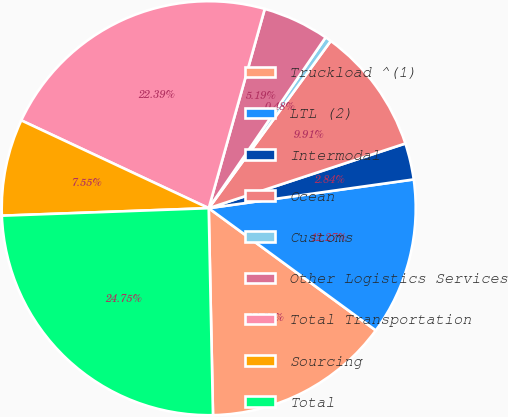Convert chart. <chart><loc_0><loc_0><loc_500><loc_500><pie_chart><fcel>Truckload ^(1)<fcel>LTL (2)<fcel>Intermodal<fcel>Ocean<fcel>Customs<fcel>Other Logistics Services<fcel>Total Transportation<fcel>Sourcing<fcel>Total<nl><fcel>14.62%<fcel>12.27%<fcel>2.84%<fcel>9.91%<fcel>0.48%<fcel>5.19%<fcel>22.39%<fcel>7.55%<fcel>24.75%<nl></chart> 